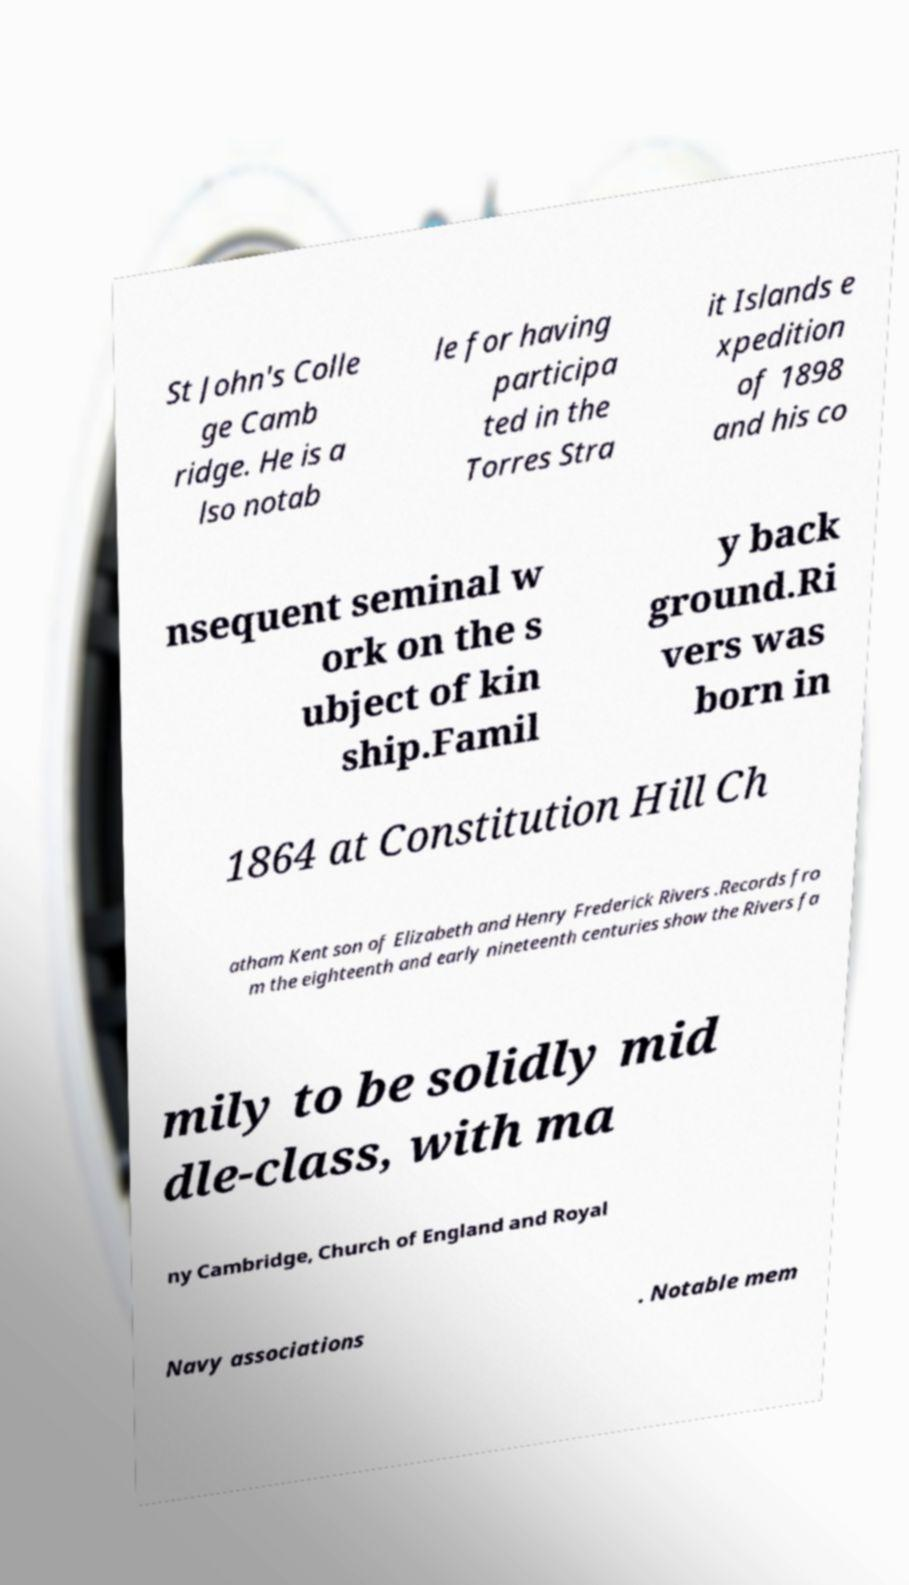Could you assist in decoding the text presented in this image and type it out clearly? St John's Colle ge Camb ridge. He is a lso notab le for having participa ted in the Torres Stra it Islands e xpedition of 1898 and his co nsequent seminal w ork on the s ubject of kin ship.Famil y back ground.Ri vers was born in 1864 at Constitution Hill Ch atham Kent son of Elizabeth and Henry Frederick Rivers .Records fro m the eighteenth and early nineteenth centuries show the Rivers fa mily to be solidly mid dle-class, with ma ny Cambridge, Church of England and Royal Navy associations . Notable mem 